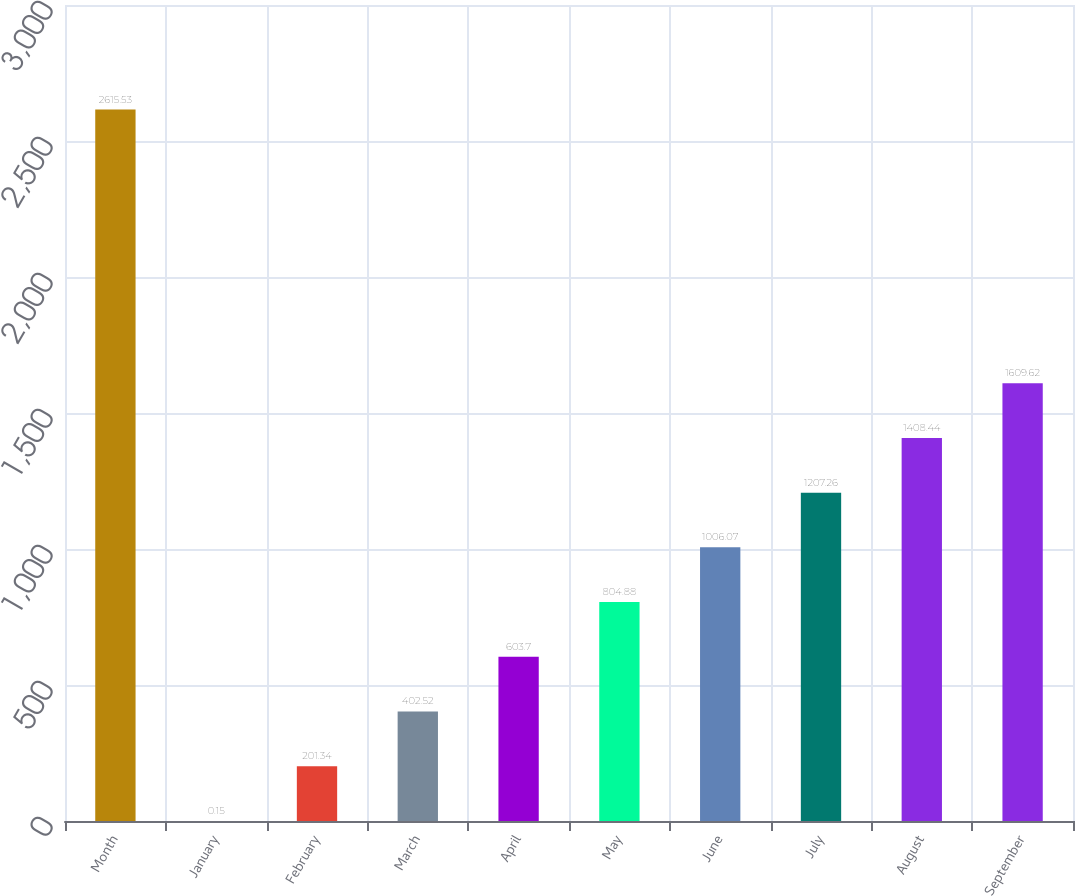Convert chart to OTSL. <chart><loc_0><loc_0><loc_500><loc_500><bar_chart><fcel>Month<fcel>January<fcel>February<fcel>March<fcel>April<fcel>May<fcel>June<fcel>July<fcel>August<fcel>September<nl><fcel>2615.53<fcel>0.15<fcel>201.34<fcel>402.52<fcel>603.7<fcel>804.88<fcel>1006.07<fcel>1207.26<fcel>1408.44<fcel>1609.62<nl></chart> 